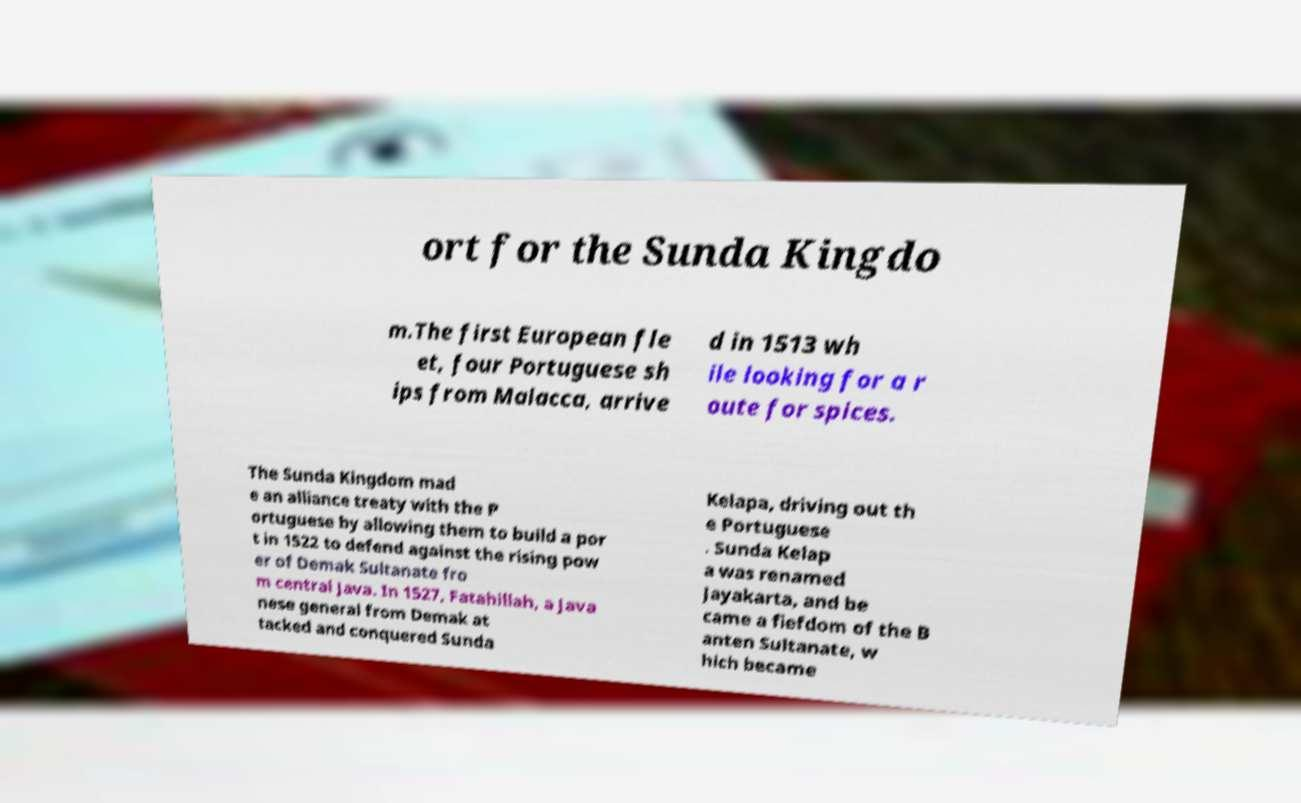For documentation purposes, I need the text within this image transcribed. Could you provide that? ort for the Sunda Kingdo m.The first European fle et, four Portuguese sh ips from Malacca, arrive d in 1513 wh ile looking for a r oute for spices. The Sunda Kingdom mad e an alliance treaty with the P ortuguese by allowing them to build a por t in 1522 to defend against the rising pow er of Demak Sultanate fro m central Java. In 1527, Fatahillah, a Java nese general from Demak at tacked and conquered Sunda Kelapa, driving out th e Portuguese . Sunda Kelap a was renamed Jayakarta, and be came a fiefdom of the B anten Sultanate, w hich became 